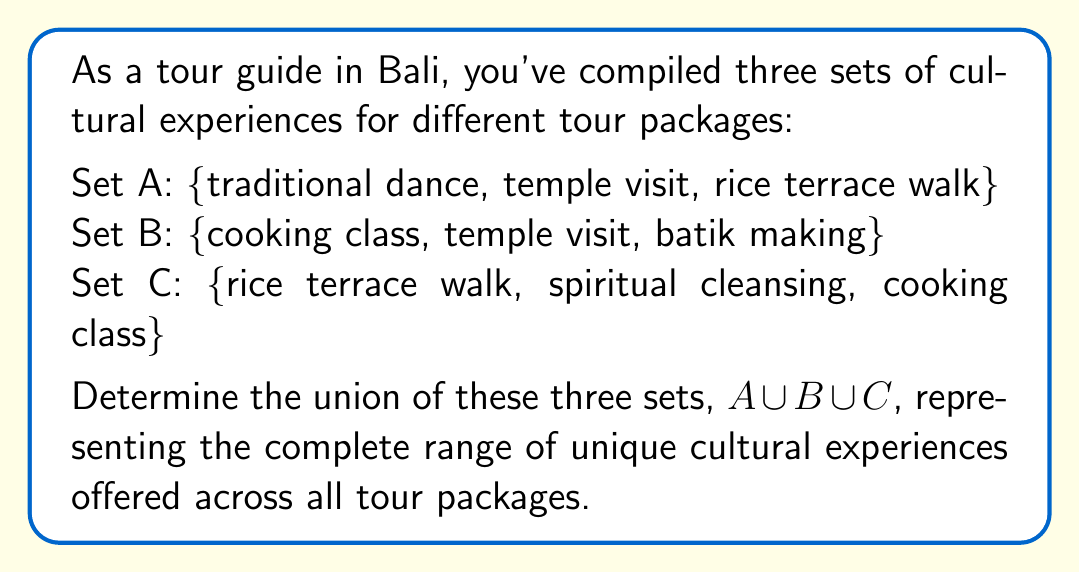Help me with this question. To find the union of sets A, B, and C, we need to combine all unique elements from each set. Let's approach this step-by-step:

1. First, let's list out all elements from each set:
   Set A: traditional dance, temple visit, rice terrace walk
   Set B: cooking class, temple visit, batik making
   Set C: rice terrace walk, spiritual cleansing, cooking class

2. Now, we'll create a new set that includes all unique elements:

   - Start with Set A: {traditional dance, temple visit, rice terrace walk}
   - Add unique elements from Set B:
     - cooking class and batik making are new, so we add them
     - temple visit is already included, so we don't add it again
   - Add unique elements from Set C:
     - spiritual cleansing is new, so we add it
     - rice terrace walk and cooking class are already included

3. The resulting union set contains all unique elements from A, B, and C:

   $A \cup B \cup C = \{$ traditional dance, temple visit, rice terrace walk, cooking class, batik making, spiritual cleansing $\}$

4. Count the elements in the union set: There are 6 unique cultural experiences in total.

This union represents the complete range of unique Balinese cultural experiences offered across all tour packages, providing a comprehensive list for tourists to choose from.
Answer: $A \cup B \cup C = \{$ traditional dance, temple visit, rice terrace walk, cooking class, batik making, spiritual cleansing $\}$ 